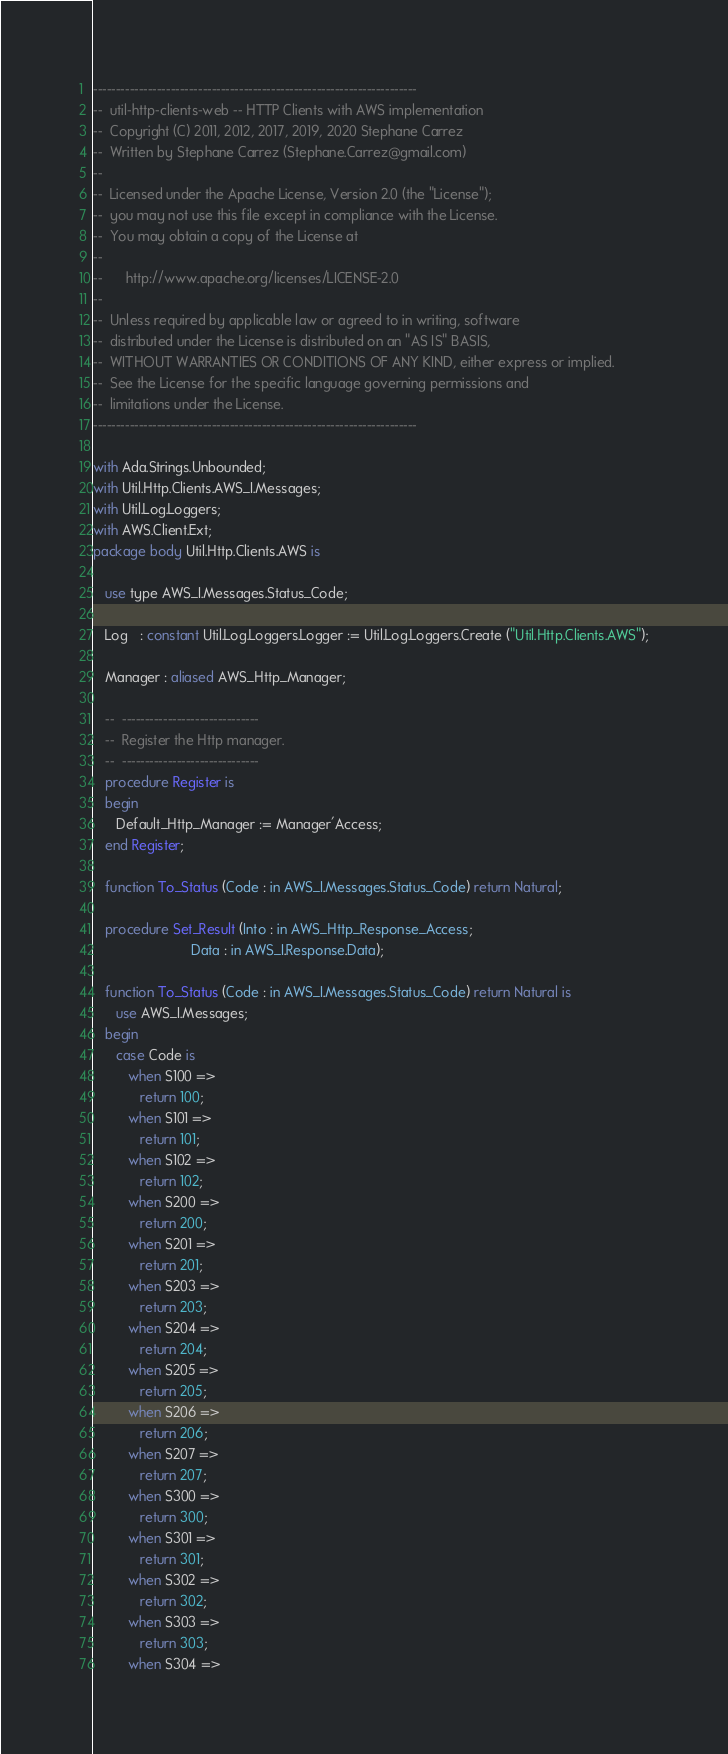Convert code to text. <code><loc_0><loc_0><loc_500><loc_500><_Ada_>-----------------------------------------------------------------------
--  util-http-clients-web -- HTTP Clients with AWS implementation
--  Copyright (C) 2011, 2012, 2017, 2019, 2020 Stephane Carrez
--  Written by Stephane Carrez (Stephane.Carrez@gmail.com)
--
--  Licensed under the Apache License, Version 2.0 (the "License");
--  you may not use this file except in compliance with the License.
--  You may obtain a copy of the License at
--
--      http://www.apache.org/licenses/LICENSE-2.0
--
--  Unless required by applicable law or agreed to in writing, software
--  distributed under the License is distributed on an "AS IS" BASIS,
--  WITHOUT WARRANTIES OR CONDITIONS OF ANY KIND, either express or implied.
--  See the License for the specific language governing permissions and
--  limitations under the License.
-----------------------------------------------------------------------

with Ada.Strings.Unbounded;
with Util.Http.Clients.AWS_I.Messages;
with Util.Log.Loggers;
with AWS.Client.Ext;
package body Util.Http.Clients.AWS is

   use type AWS_I.Messages.Status_Code;

   Log   : constant Util.Log.Loggers.Logger := Util.Log.Loggers.Create ("Util.Http.Clients.AWS");

   Manager : aliased AWS_Http_Manager;

   --  ------------------------------
   --  Register the Http manager.
   --  ------------------------------
   procedure Register is
   begin
      Default_Http_Manager := Manager'Access;
   end Register;

   function To_Status (Code : in AWS_I.Messages.Status_Code) return Natural;

   procedure Set_Result (Into : in AWS_Http_Response_Access;
                         Data : in AWS_I.Response.Data);

   function To_Status (Code : in AWS_I.Messages.Status_Code) return Natural is
      use AWS_I.Messages;
   begin
      case Code is
         when S100 =>
            return 100;
         when S101 =>
            return 101;
         when S102 =>
            return 102;
         when S200 =>
            return 200;
         when S201 =>
            return 201;
         when S203 =>
            return 203;
         when S204 =>
            return 204;
         when S205 =>
            return 205;
         when S206 =>
            return 206;
         when S207 =>
            return 207;
         when S300 =>
            return 300;
         when S301 =>
            return 301;
         when S302 =>
            return 302;
         when S303 =>
            return 303;
         when S304 =></code> 